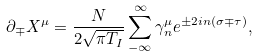<formula> <loc_0><loc_0><loc_500><loc_500>\partial _ { \mp } X ^ { \mu } = \frac { N } { 2 \sqrt { \pi T _ { I } } } \sum _ { - \infty } ^ { \infty } \gamma _ { n } ^ { \mu } e ^ { \pm 2 i n ( \sigma \mp \tau ) } ,</formula> 